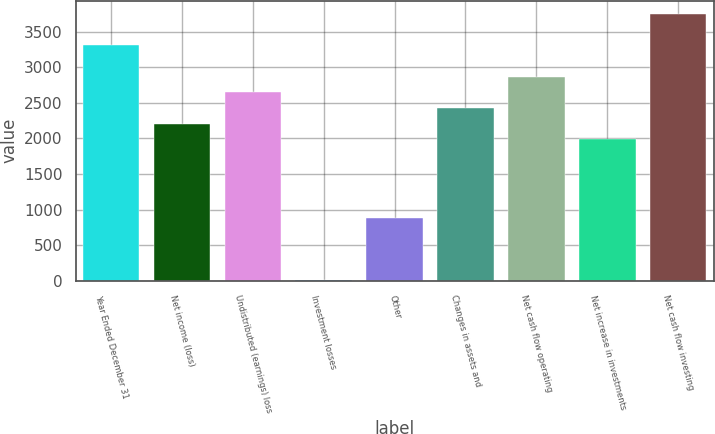<chart> <loc_0><loc_0><loc_500><loc_500><bar_chart><fcel>Year Ended December 31<fcel>Net income (loss)<fcel>Undistributed (earnings) loss<fcel>Investment losses<fcel>Other<fcel>Changes in assets and<fcel>Net cash flow operating<fcel>Net increase in investments<fcel>Net cash flow investing<nl><fcel>3311.1<fcel>2208.2<fcel>2649.36<fcel>2.4<fcel>884.72<fcel>2428.78<fcel>2869.94<fcel>1987.62<fcel>3752.26<nl></chart> 